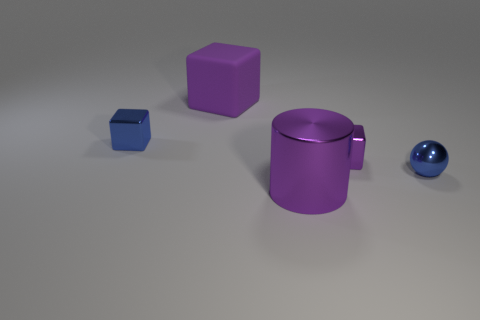There is a shiny sphere that is the same size as the blue block; what color is it?
Provide a succinct answer. Blue. The blue thing on the left side of the blue ball in front of the tiny purple block is what shape?
Keep it short and to the point. Cube. There is a metallic thing that is on the left side of the rubber block; does it have the same size as the blue metallic ball?
Make the answer very short. Yes. How many other things are there of the same material as the blue cube?
Give a very brief answer. 3. What number of yellow things are either metal spheres or small shiny cubes?
Your response must be concise. 0. There is a matte cube that is the same color as the cylinder; what size is it?
Keep it short and to the point. Large. There is a purple metal block; what number of small blue metallic objects are to the right of it?
Ensure brevity in your answer.  1. What size is the purple block that is left of the block that is right of the shiny object in front of the metallic ball?
Give a very brief answer. Large. There is a big purple object that is behind the metallic cube that is left of the purple metallic cylinder; are there any large purple blocks that are in front of it?
Provide a short and direct response. No. Are there more big gray shiny cubes than balls?
Your answer should be compact. No. 